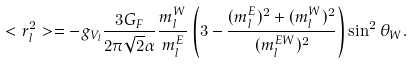<formula> <loc_0><loc_0><loc_500><loc_500>< r ^ { 2 } _ { l } > = - g _ { V _ { l } } \frac { 3 G _ { F } } { 2 \pi \sqrt { 2 } \alpha } \frac { m _ { l } ^ { W } } { m _ { l } ^ { E } } \left ( 3 - \frac { ( m _ { l } ^ { E } ) ^ { 2 } + ( m _ { l } ^ { W } ) ^ { 2 } } { ( m _ { l } ^ { E W } ) ^ { 2 } } \right ) \sin ^ { 2 } \theta _ { W } .</formula> 